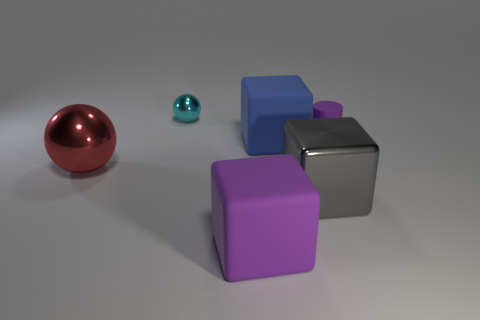Is the number of tiny purple objects to the left of the large metallic cube the same as the number of big green shiny cubes?
Ensure brevity in your answer.  Yes. Are there any other things that have the same shape as the large gray metal object?
Your answer should be very brief. Yes. There is a small purple thing; does it have the same shape as the large object that is behind the red shiny sphere?
Provide a succinct answer. No. The gray thing that is the same shape as the blue matte object is what size?
Offer a terse response. Large. What number of other objects are the same material as the blue block?
Ensure brevity in your answer.  2. What is the material of the small cylinder?
Offer a very short reply. Rubber. There is a small object left of the purple block; is its color the same as the shiny sphere in front of the cylinder?
Provide a short and direct response. No. Is the number of tiny shiny objects that are in front of the tiny matte object greater than the number of tiny shiny objects?
Offer a very short reply. No. How many other things are there of the same color as the small cylinder?
Ensure brevity in your answer.  1. There is a purple object in front of the purple matte cylinder; does it have the same size as the small purple rubber thing?
Your response must be concise. No. 